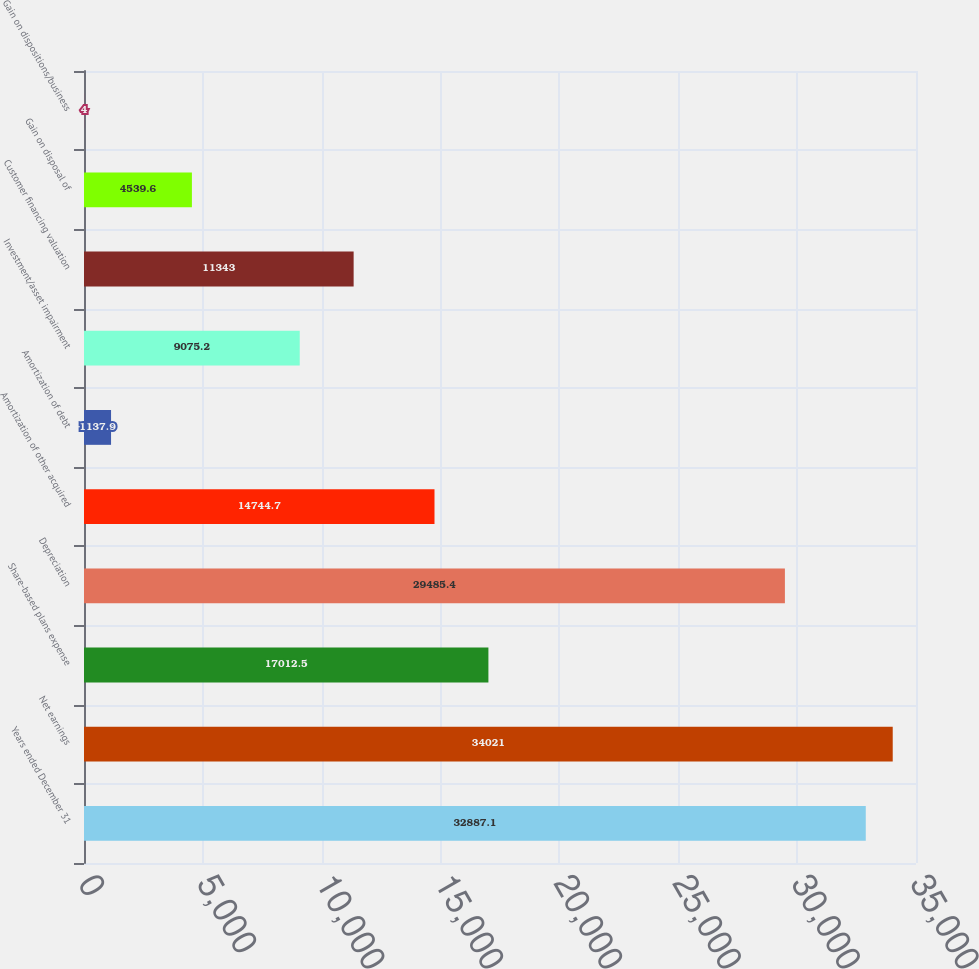Convert chart. <chart><loc_0><loc_0><loc_500><loc_500><bar_chart><fcel>Years ended December 31<fcel>Net earnings<fcel>Share-based plans expense<fcel>Depreciation<fcel>Amortization of other acquired<fcel>Amortization of debt<fcel>Investment/asset impairment<fcel>Customer financing valuation<fcel>Gain on disposal of<fcel>Gain on dispositions/business<nl><fcel>32887.1<fcel>34021<fcel>17012.5<fcel>29485.4<fcel>14744.7<fcel>1137.9<fcel>9075.2<fcel>11343<fcel>4539.6<fcel>4<nl></chart> 